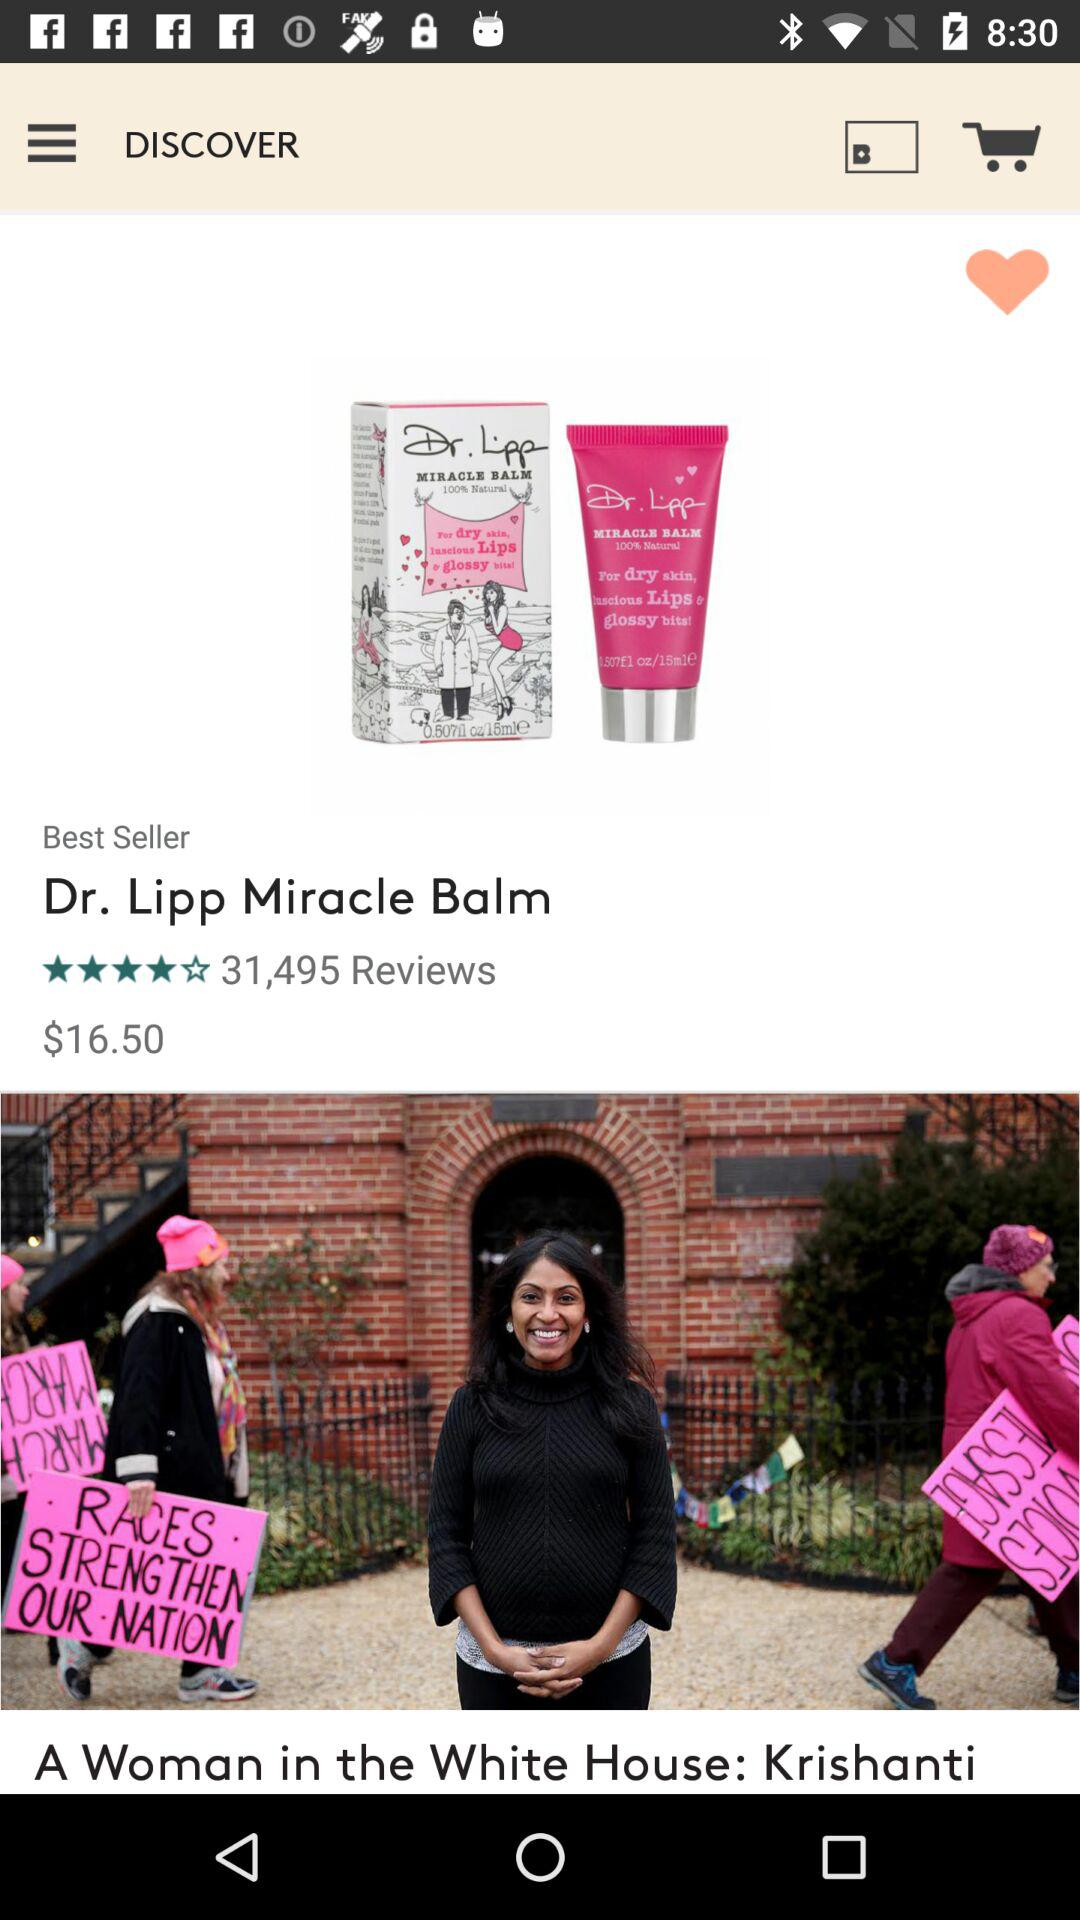What is the name of the product? The product name is "Dr. Lipp Miracle Balm". 